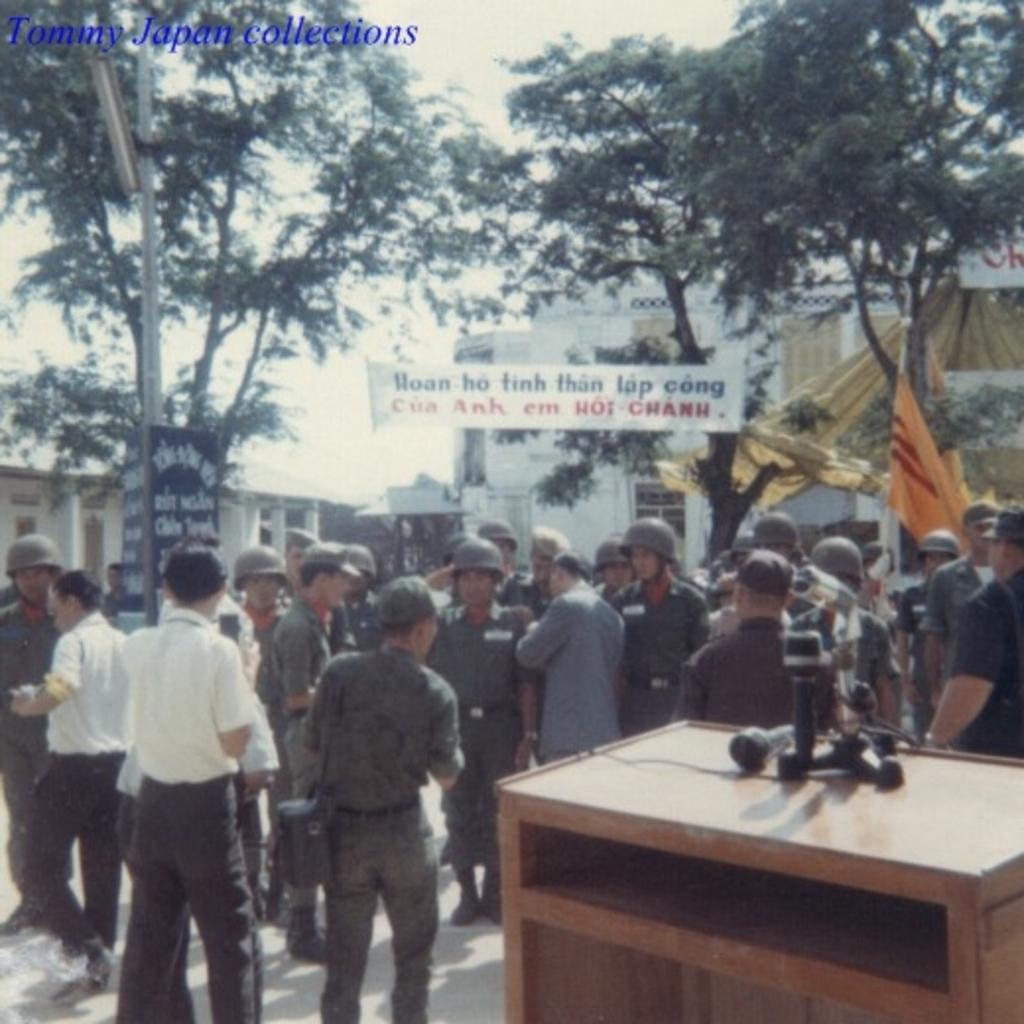Could you give a brief overview of what you see in this image? In this picture there are a group of people standing there is a table here and there is a banner over here are some buildings trees and the sky is clear 